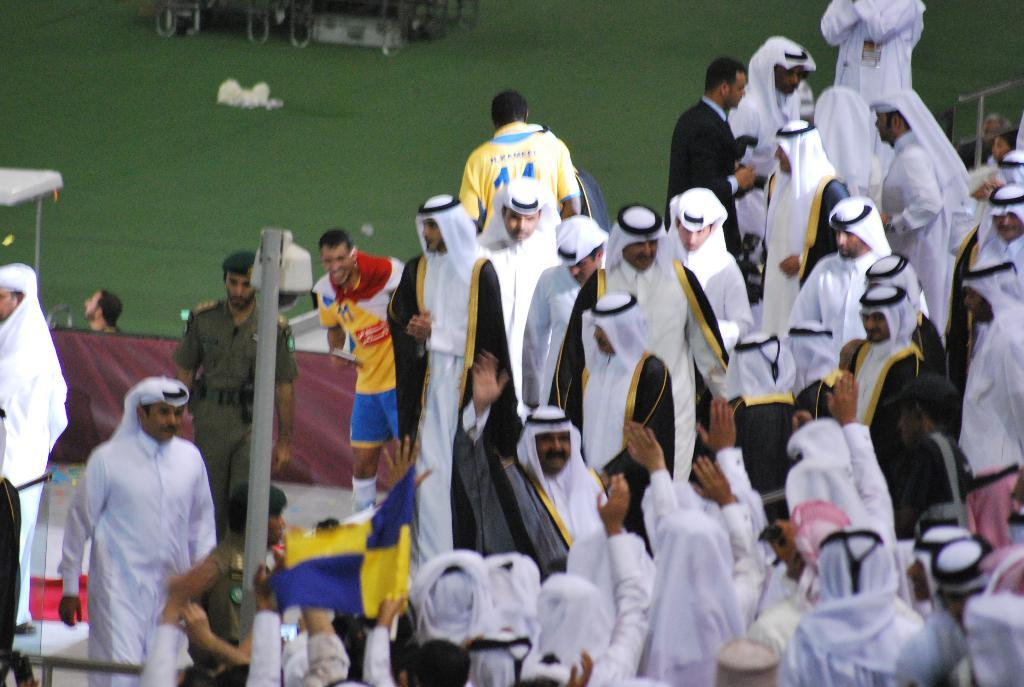What type of people can be seen in the image? There are many Arab men in the image. What are the men doing in the image? The men are standing and walking. What can be seen on the left side of the image? There is grassland on the left side of the image. Can you see a mountain in the background of the image? There is no mountain visible in the image; it only shows Arab men standing and walking, and grassland on the left side. 